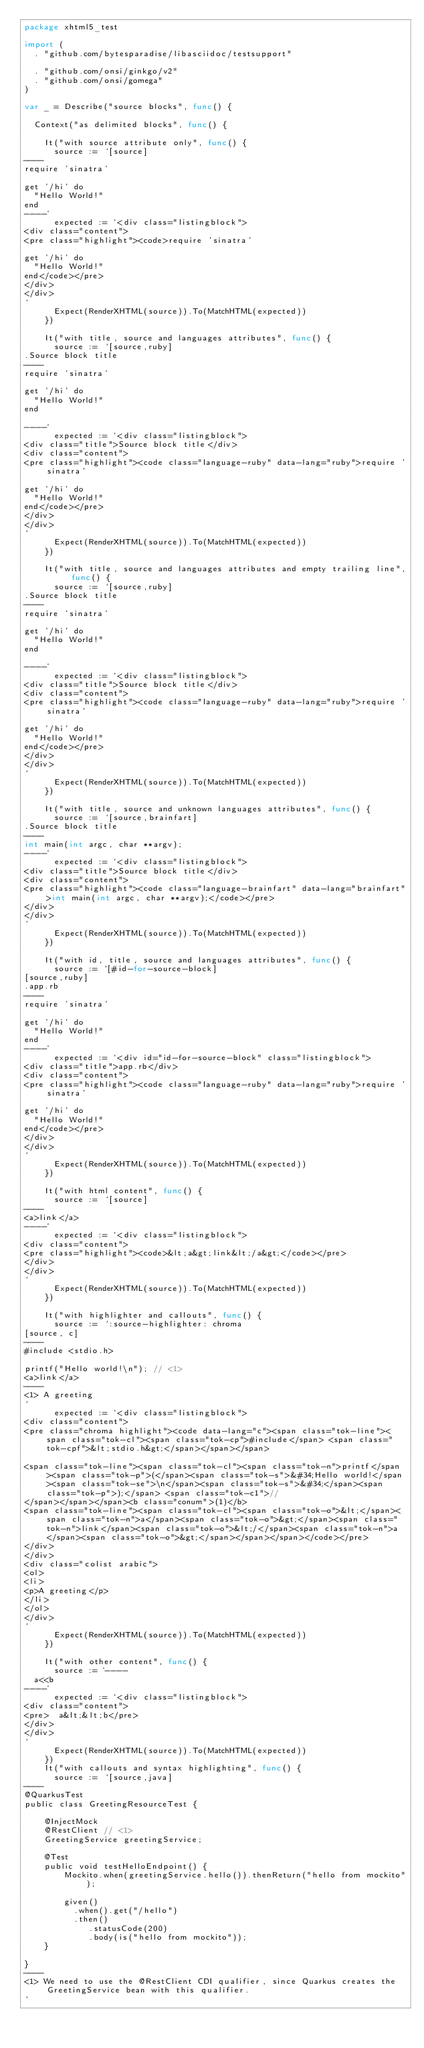<code> <loc_0><loc_0><loc_500><loc_500><_Go_>package xhtml5_test

import (
	. "github.com/bytesparadise/libasciidoc/testsupport"

	. "github.com/onsi/ginkgo/v2"
	. "github.com/onsi/gomega"
)

var _ = Describe("source blocks", func() {

	Context("as delimited blocks", func() {

		It("with source attribute only", func() {
			source := `[source]
----
require 'sinatra'

get '/hi' do
  "Hello World!"
end
----`
			expected := `<div class="listingblock">
<div class="content">
<pre class="highlight"><code>require 'sinatra'

get '/hi' do
  "Hello World!"
end</code></pre>
</div>
</div>
`
			Expect(RenderXHTML(source)).To(MatchHTML(expected))
		})

		It("with title, source and languages attributes", func() {
			source := `[source,ruby]
.Source block title
----
require 'sinatra'

get '/hi' do
  "Hello World!"
end

----`
			expected := `<div class="listingblock">
<div class="title">Source block title</div>
<div class="content">
<pre class="highlight"><code class="language-ruby" data-lang="ruby">require 'sinatra'

get '/hi' do
  "Hello World!"
end</code></pre>
</div>
</div>
`
			Expect(RenderXHTML(source)).To(MatchHTML(expected))
		})

		It("with title, source and languages attributes and empty trailing line", func() {
			source := `[source,ruby]
.Source block title
----
require 'sinatra'

get '/hi' do
  "Hello World!"
end

----`
			expected := `<div class="listingblock">
<div class="title">Source block title</div>
<div class="content">
<pre class="highlight"><code class="language-ruby" data-lang="ruby">require 'sinatra'

get '/hi' do
  "Hello World!"
end</code></pre>
</div>
</div>
`
			Expect(RenderXHTML(source)).To(MatchHTML(expected))
		})

		It("with title, source and unknown languages attributes", func() {
			source := `[source,brainfart]
.Source block title
----
int main(int argc, char **argv);
----`
			expected := `<div class="listingblock">
<div class="title">Source block title</div>
<div class="content">
<pre class="highlight"><code class="language-brainfart" data-lang="brainfart">int main(int argc, char **argv);</code></pre>
</div>
</div>
`
			Expect(RenderXHTML(source)).To(MatchHTML(expected))
		})

		It("with id, title, source and languages attributes", func() {
			source := `[#id-for-source-block]
[source,ruby]
.app.rb
----
require 'sinatra'

get '/hi' do
  "Hello World!"
end
----`
			expected := `<div id="id-for-source-block" class="listingblock">
<div class="title">app.rb</div>
<div class="content">
<pre class="highlight"><code class="language-ruby" data-lang="ruby">require 'sinatra'

get '/hi' do
  "Hello World!"
end</code></pre>
</div>
</div>
`
			Expect(RenderXHTML(source)).To(MatchHTML(expected))
		})

		It("with html content", func() {
			source := `[source]
----
<a>link</a>
----`
			expected := `<div class="listingblock">
<div class="content">
<pre class="highlight"><code>&lt;a&gt;link&lt;/a&gt;</code></pre>
</div>
</div>
`
			Expect(RenderXHTML(source)).To(MatchHTML(expected))
		})

		It("with highlighter and callouts", func() {
			source := `:source-highlighter: chroma
[source, c]
----
#include <stdio.h>

printf("Hello world!\n"); // <1>
<a>link</a>
----
<1> A greeting
`
			expected := `<div class="listingblock">
<div class="content">
<pre class="chroma highlight"><code data-lang="c"><span class="tok-line"><span class="tok-cl"><span class="tok-cp">#include</span> <span class="tok-cpf">&lt;stdio.h&gt;</span></span></span>

<span class="tok-line"><span class="tok-cl"><span class="tok-n">printf</span><span class="tok-p">(</span><span class="tok-s">&#34;Hello world!</span><span class="tok-se">\n</span><span class="tok-s">&#34;</span><span class="tok-p">);</span> <span class="tok-c1">// 
</span></span></span><b class="conum">(1)</b>
<span class="tok-line"><span class="tok-cl"><span class="tok-o">&lt;</span><span class="tok-n">a</span><span class="tok-o">&gt;</span><span class="tok-n">link</span><span class="tok-o">&lt;/</span><span class="tok-n">a</span><span class="tok-o">&gt;</span></span></span></code></pre>
</div>
</div>
<div class="colist arabic">
<ol>
<li>
<p>A greeting</p>
</li>
</ol>
</div>
`
			Expect(RenderXHTML(source)).To(MatchHTML(expected))
		})

		It("with other content", func() {
			source := `----
  a<<b
----`
			expected := `<div class="listingblock">
<div class="content">
<pre>  a&lt;&lt;b</pre>
</div>
</div>
`
			Expect(RenderXHTML(source)).To(MatchHTML(expected))
		})
		It("with callouts and syntax highlighting", func() {
			source := `[source,java]
----
@QuarkusTest
public class GreetingResourceTest {

    @InjectMock
    @RestClient // <1>
    GreetingService greetingService;

    @Test
    public void testHelloEndpoint() {
        Mockito.when(greetingService.hello()).thenReturn("hello from mockito");

        given()
          .when().get("/hello")
          .then()
             .statusCode(200)
             .body(is("hello from mockito"));
    }

}
----
<1> We need to use the @RestClient CDI qualifier, since Quarkus creates the GreetingService bean with this qualifier.
`</code> 